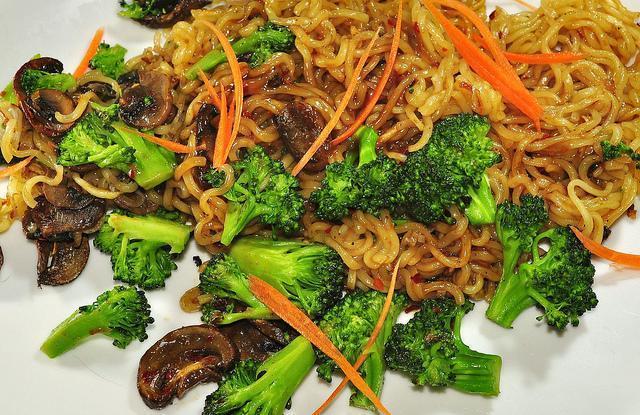How many broccolis are there?
Give a very brief answer. 11. How many carrots are there?
Give a very brief answer. 2. How many people in this image are wearing a white jacket?
Give a very brief answer. 0. 